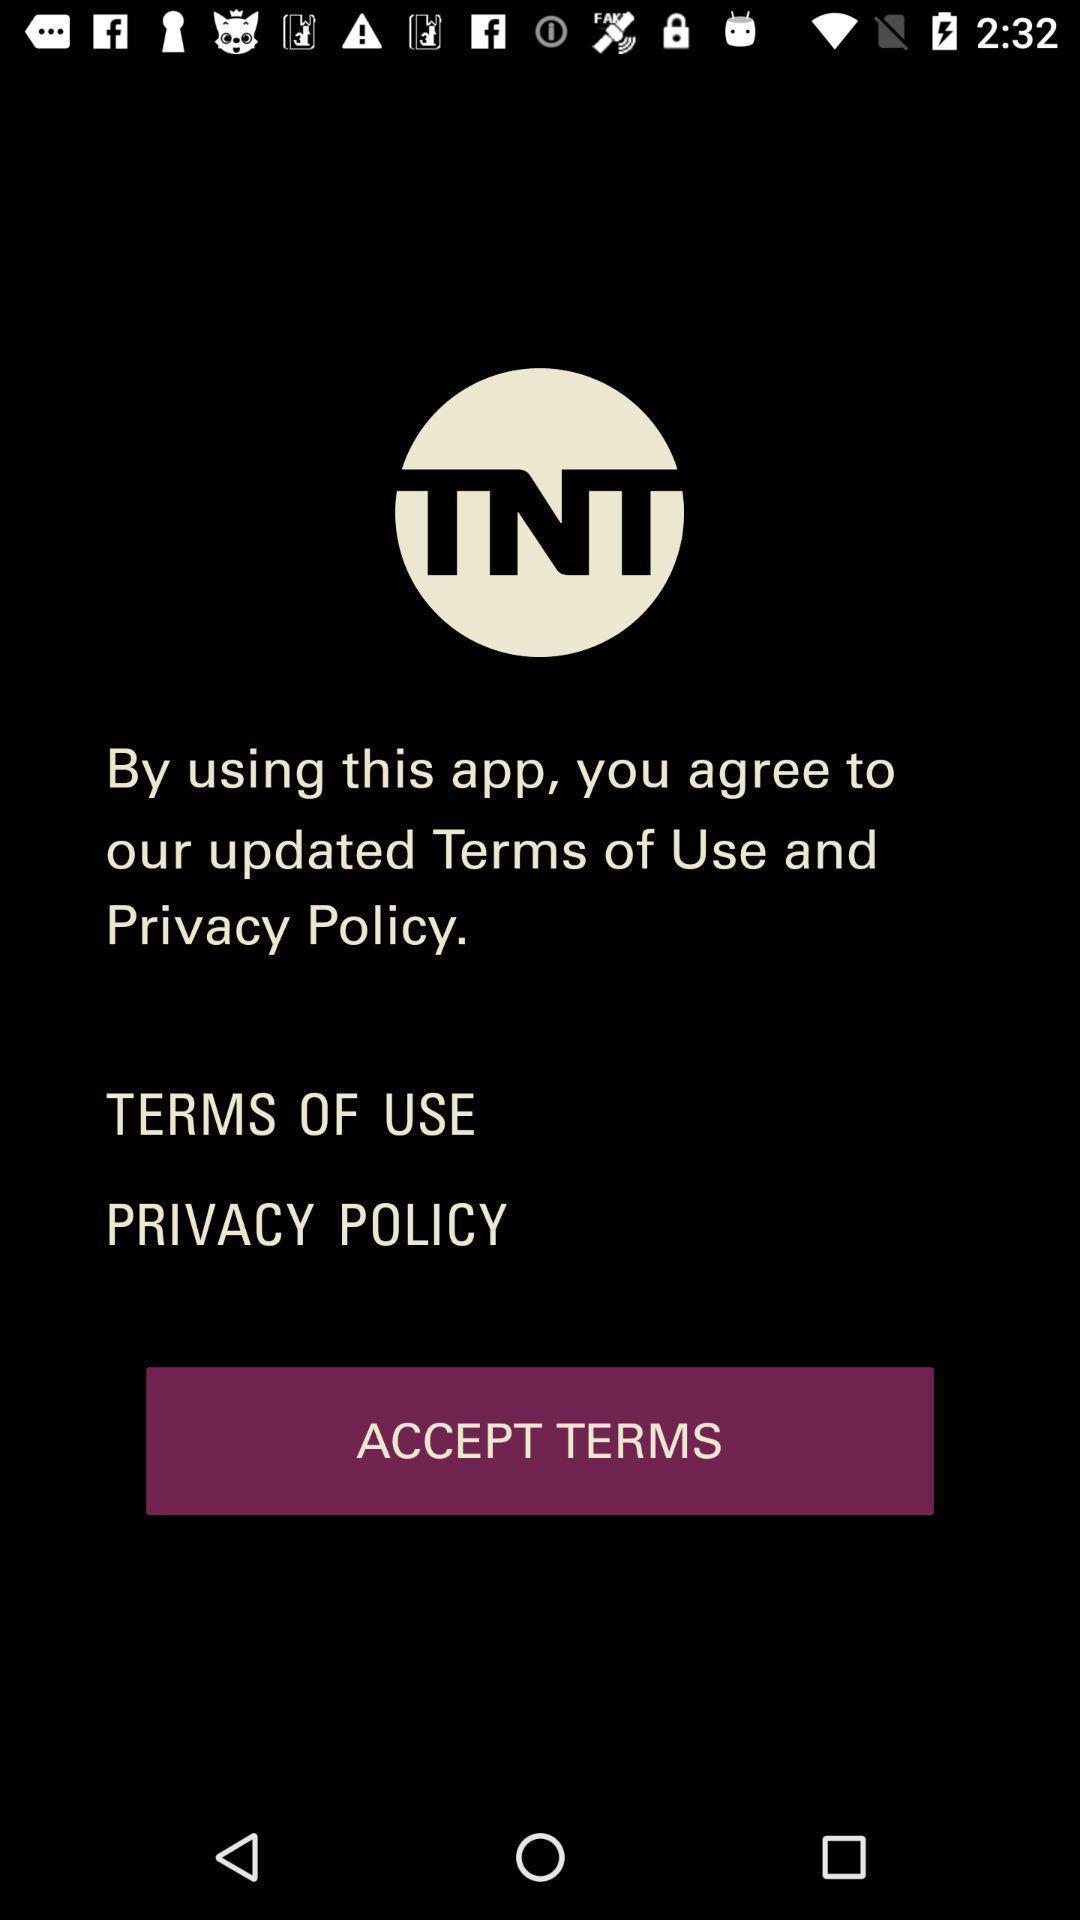What details can you identify in this image? Screen showing privacy policy. 